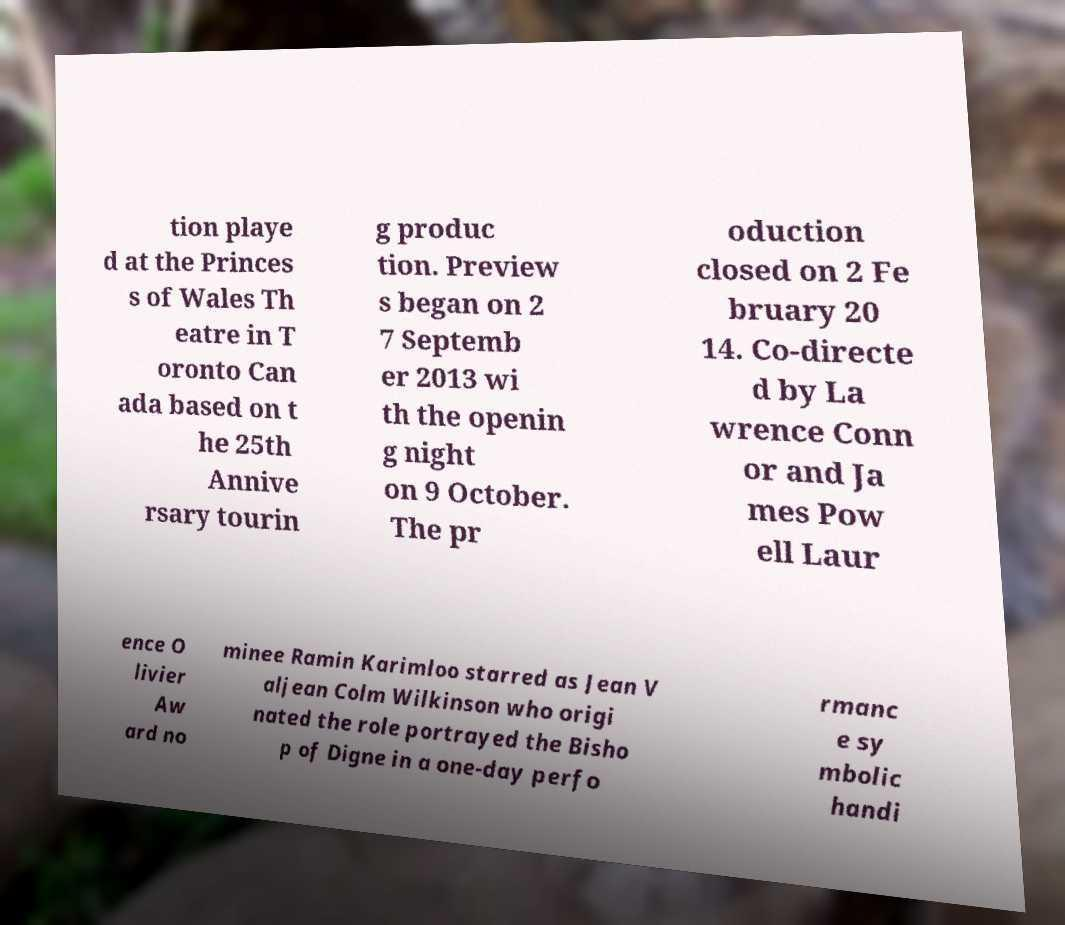Please identify and transcribe the text found in this image. tion playe d at the Princes s of Wales Th eatre in T oronto Can ada based on t he 25th Annive rsary tourin g produc tion. Preview s began on 2 7 Septemb er 2013 wi th the openin g night on 9 October. The pr oduction closed on 2 Fe bruary 20 14. Co-directe d by La wrence Conn or and Ja mes Pow ell Laur ence O livier Aw ard no minee Ramin Karimloo starred as Jean V aljean Colm Wilkinson who origi nated the role portrayed the Bisho p of Digne in a one-day perfo rmanc e sy mbolic handi 